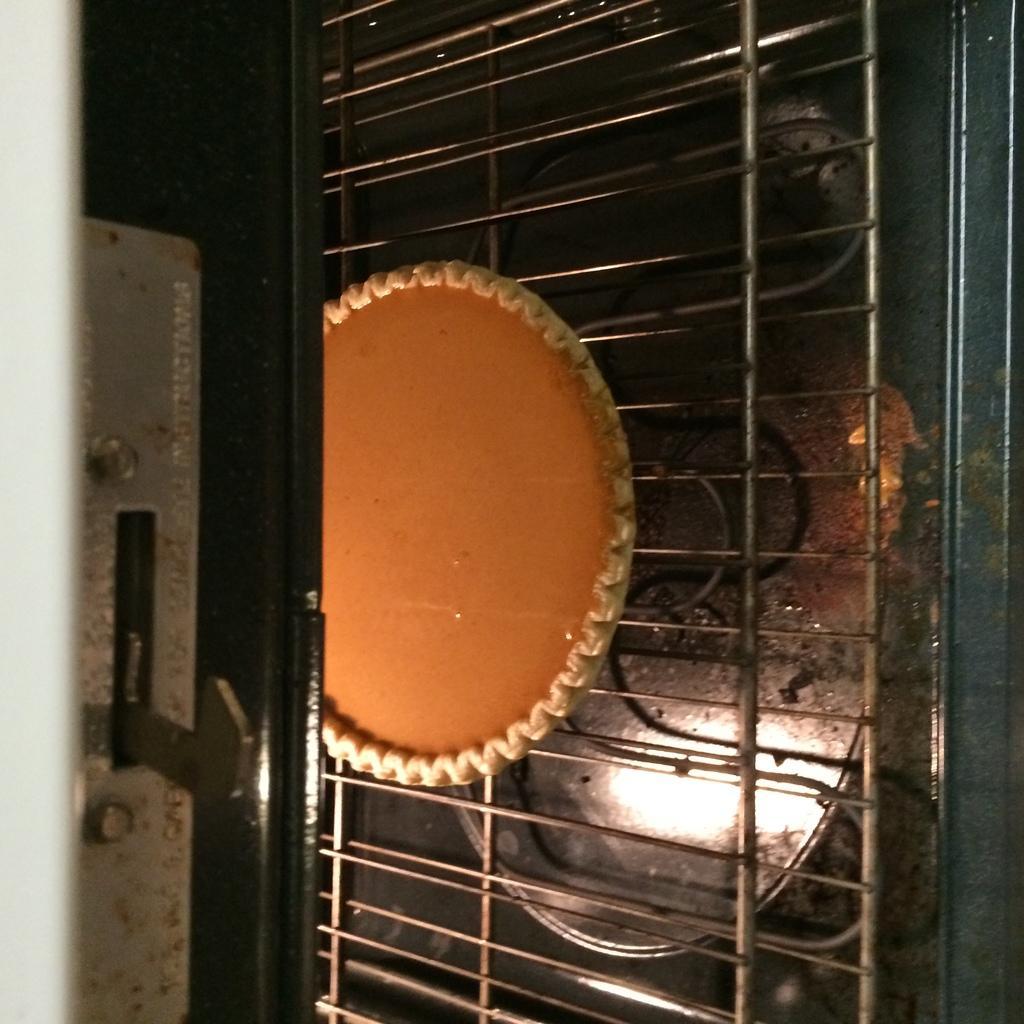How would you summarize this image in a sentence or two? In the center of the image we can see baking pan in oven and also we can see grills. 